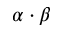Convert formula to latex. <formula><loc_0><loc_0><loc_500><loc_500>{ \alpha \cdot \beta }</formula> 